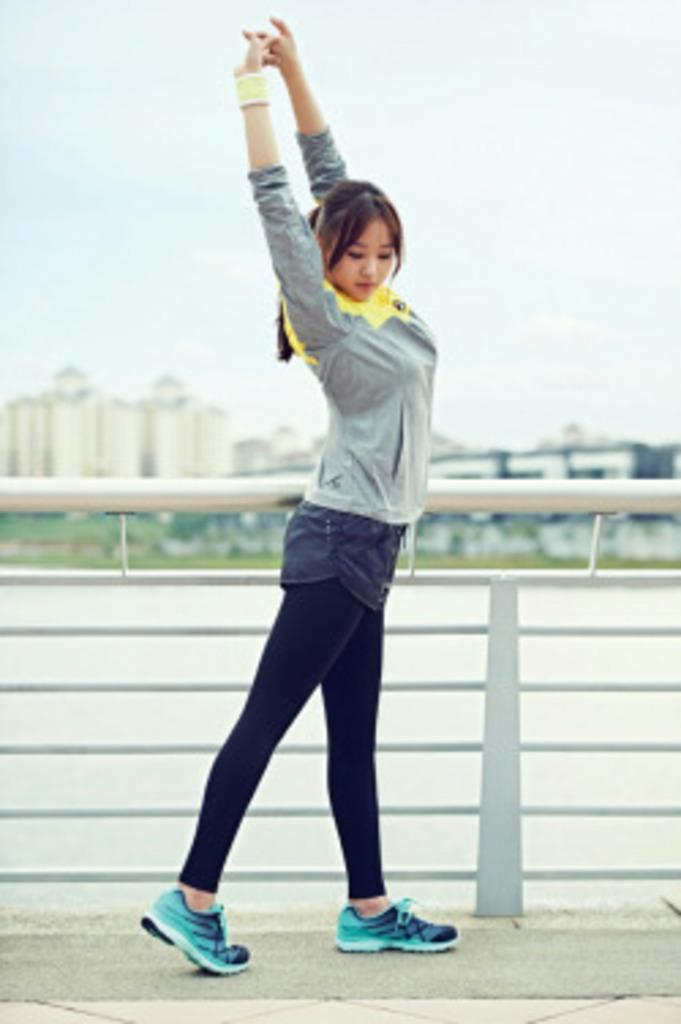What is the main subject of the image? There is a person standing in the image. Where is the person standing? The person is standing on the ground. What can be seen behind the person? There is a fence behind the person. What type of vegetation is visible in the image? There is grass visible in the image. What structures can be seen in the background of the image? There are buildings in the background of the image. What is visible at the top of the image? The sky is visible at the top of the image. How many pieces of popcorn are scattered on the ground in the image? There is no popcorn present in the image. What type of cent is depicted on the fence in the image? There is no cent depicted on the fence in the image. 